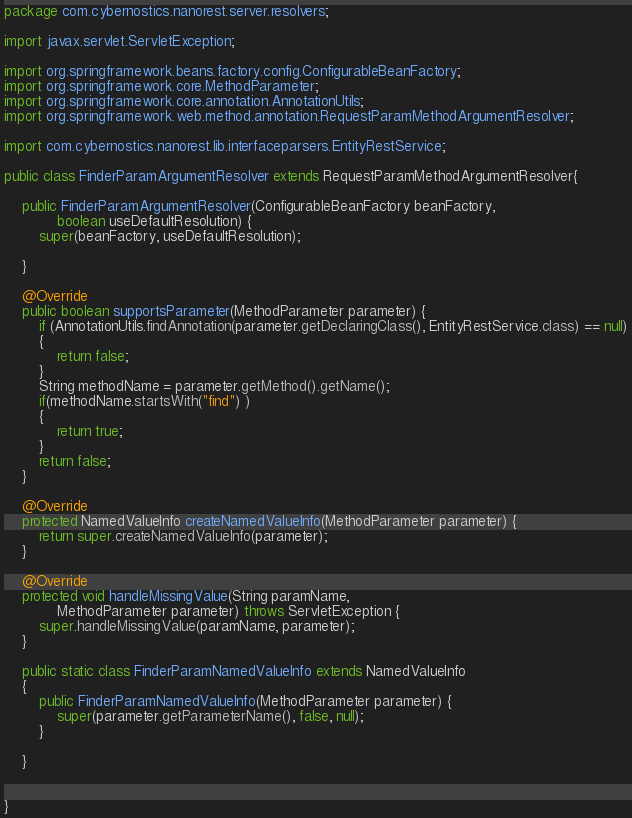Convert code to text. <code><loc_0><loc_0><loc_500><loc_500><_Java_>package com.cybernostics.nanorest.server.resolvers;

import javax.servlet.ServletException;

import org.springframework.beans.factory.config.ConfigurableBeanFactory;
import org.springframework.core.MethodParameter;
import org.springframework.core.annotation.AnnotationUtils;
import org.springframework.web.method.annotation.RequestParamMethodArgumentResolver;

import com.cybernostics.nanorest.lib.interfaceparsers.EntityRestService;

public class FinderParamArgumentResolver extends RequestParamMethodArgumentResolver{

	public FinderParamArgumentResolver(ConfigurableBeanFactory beanFactory,
			boolean useDefaultResolution) {
		super(beanFactory, useDefaultResolution);

	}

	@Override
	public boolean supportsParameter(MethodParameter parameter) {
		if (AnnotationUtils.findAnnotation(parameter.getDeclaringClass(), EntityRestService.class) == null)
		{
			return false;
		}
		String methodName = parameter.getMethod().getName();
		if(methodName.startsWith("find") )
		{
			return true;
		}
		return false;
	}

	@Override
	protected NamedValueInfo createNamedValueInfo(MethodParameter parameter) {
		return super.createNamedValueInfo(parameter);
	}

	@Override
	protected void handleMissingValue(String paramName,
			MethodParameter parameter) throws ServletException {
		super.handleMissingValue(paramName, parameter);
	}

	public static class FinderParamNamedValueInfo extends NamedValueInfo
	{
		public FinderParamNamedValueInfo(MethodParameter parameter) {
			super(parameter.getParameterName(), false, null);
		}

	}


}
</code> 